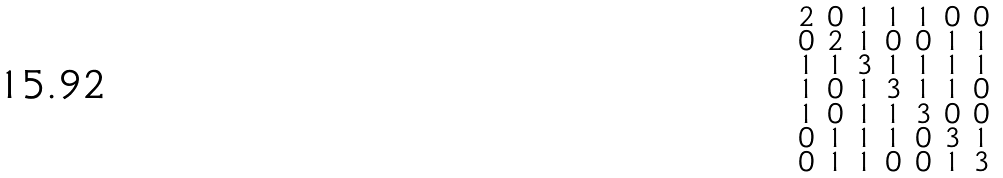<formula> <loc_0><loc_0><loc_500><loc_500>\begin{smallmatrix} 2 & 0 & 1 & 1 & 1 & 0 & 0 \\ 0 & 2 & 1 & 0 & 0 & 1 & 1 \\ 1 & 1 & 3 & 1 & 1 & 1 & 1 \\ 1 & 0 & 1 & 3 & 1 & 1 & 0 \\ 1 & 0 & 1 & 1 & 3 & 0 & 0 \\ 0 & 1 & 1 & 1 & 0 & 3 & 1 \\ 0 & 1 & 1 & 0 & 0 & 1 & 3 \end{smallmatrix}</formula> 